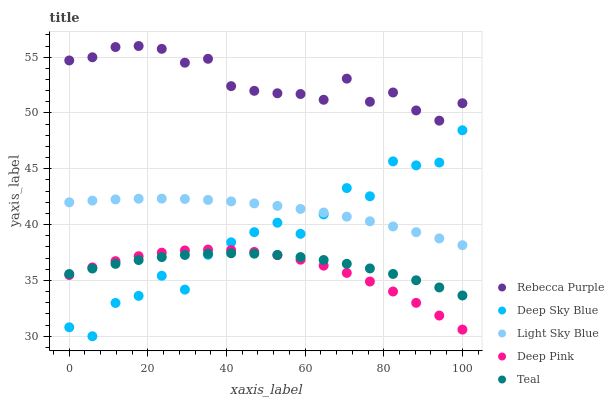Does Deep Pink have the minimum area under the curve?
Answer yes or no. Yes. Does Rebecca Purple have the maximum area under the curve?
Answer yes or no. Yes. Does Light Sky Blue have the minimum area under the curve?
Answer yes or no. No. Does Light Sky Blue have the maximum area under the curve?
Answer yes or no. No. Is Light Sky Blue the smoothest?
Answer yes or no. Yes. Is Deep Sky Blue the roughest?
Answer yes or no. Yes. Is Rebecca Purple the smoothest?
Answer yes or no. No. Is Rebecca Purple the roughest?
Answer yes or no. No. Does Deep Sky Blue have the lowest value?
Answer yes or no. Yes. Does Light Sky Blue have the lowest value?
Answer yes or no. No. Does Rebecca Purple have the highest value?
Answer yes or no. Yes. Does Light Sky Blue have the highest value?
Answer yes or no. No. Is Light Sky Blue less than Rebecca Purple?
Answer yes or no. Yes. Is Rebecca Purple greater than Light Sky Blue?
Answer yes or no. Yes. Does Teal intersect Deep Sky Blue?
Answer yes or no. Yes. Is Teal less than Deep Sky Blue?
Answer yes or no. No. Is Teal greater than Deep Sky Blue?
Answer yes or no. No. Does Light Sky Blue intersect Rebecca Purple?
Answer yes or no. No. 